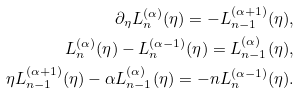<formula> <loc_0><loc_0><loc_500><loc_500>\partial _ { \eta } L _ { n } ^ { ( \alpha ) } ( \eta ) = - L _ { n - 1 } ^ { ( \alpha + 1 ) } ( \eta ) , \\ L _ { n } ^ { ( \alpha ) } ( \eta ) - L _ { n } ^ { ( \alpha - 1 ) } ( \eta ) = L _ { n - 1 } ^ { ( \alpha ) } ( \eta ) , \\ \eta L _ { n - 1 } ^ { ( \alpha + 1 ) } ( \eta ) - \alpha L _ { n - 1 } ^ { ( \alpha ) } ( \eta ) = - n L _ { n } ^ { ( \alpha - 1 ) } ( \eta ) .</formula> 